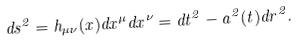Convert formula to latex. <formula><loc_0><loc_0><loc_500><loc_500>d s ^ { 2 } = h _ { \mu \nu } ( x ) d x ^ { \mu } d x ^ { \nu } = d t ^ { 2 } - a ^ { 2 } ( t ) d r ^ { 2 } .</formula> 